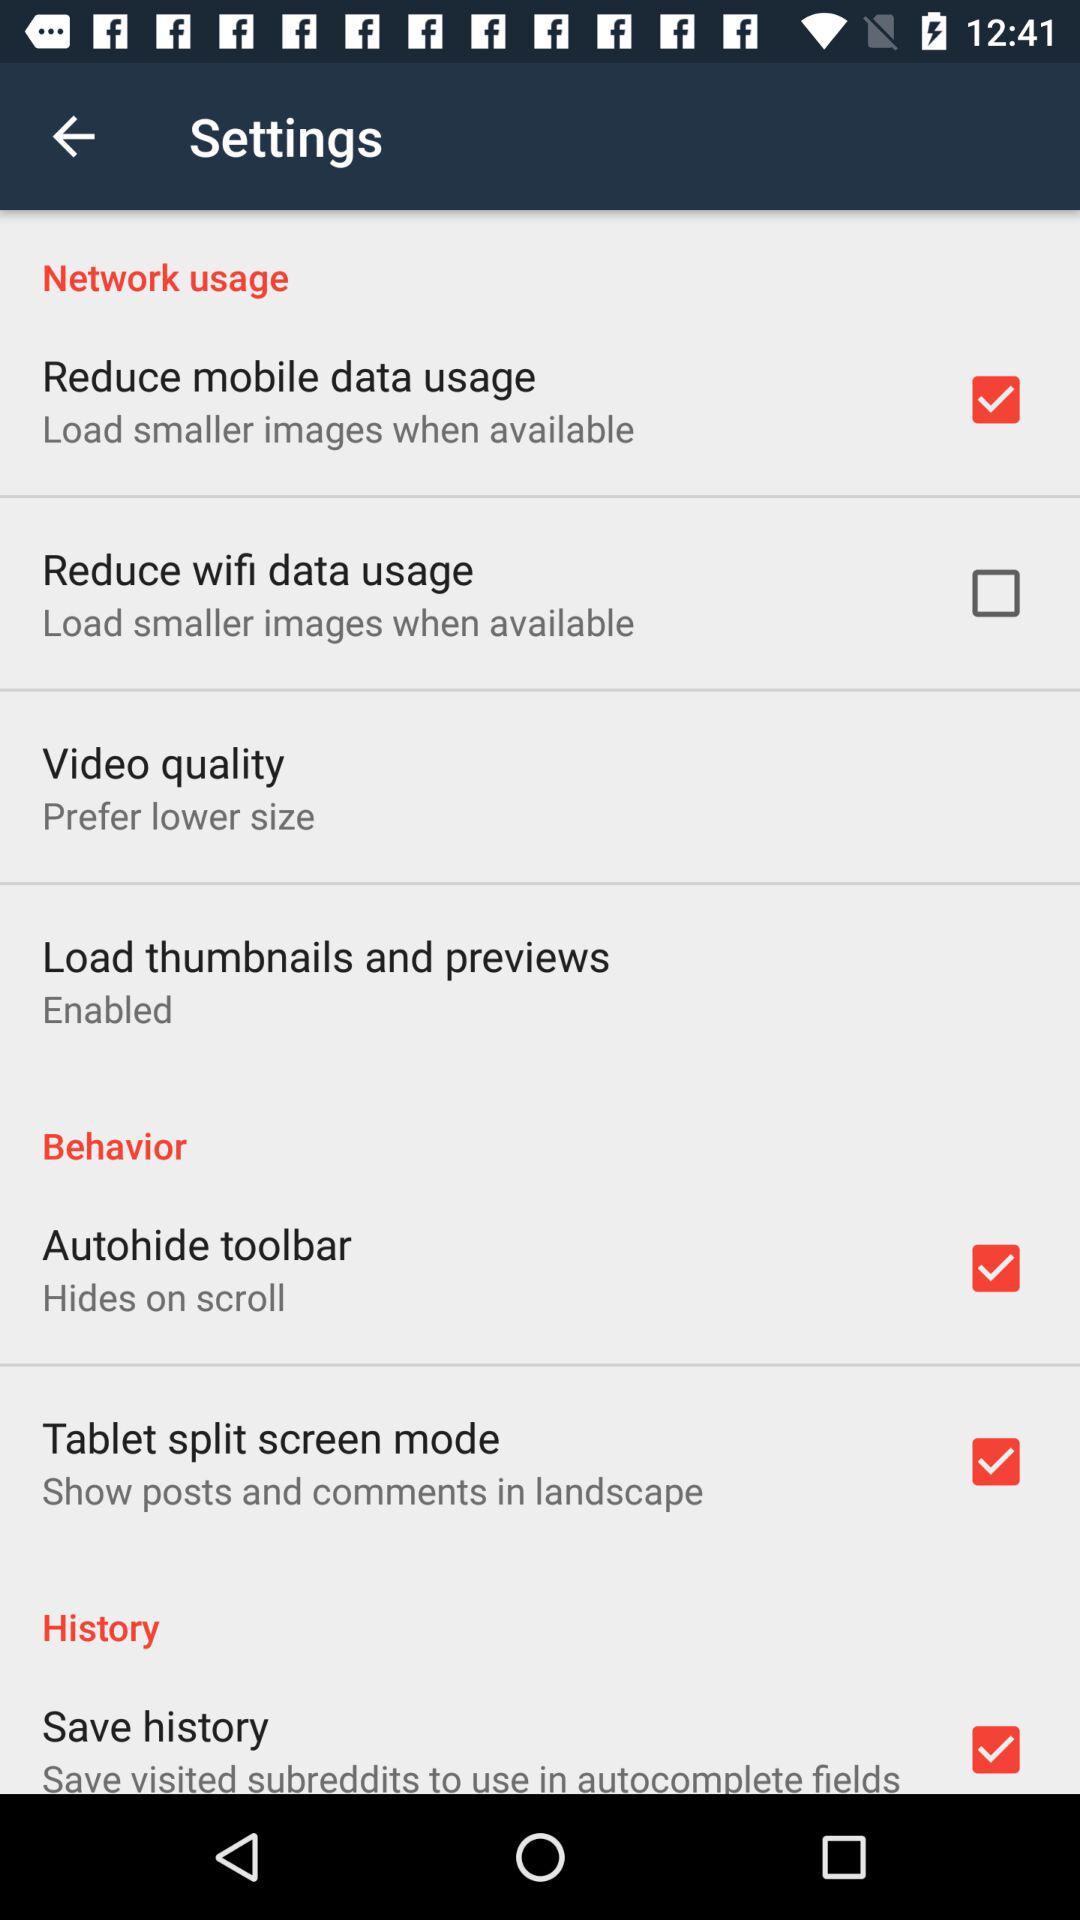What is the selected "Video quality"? The selected "Video quality" is "Prefer lower size". 